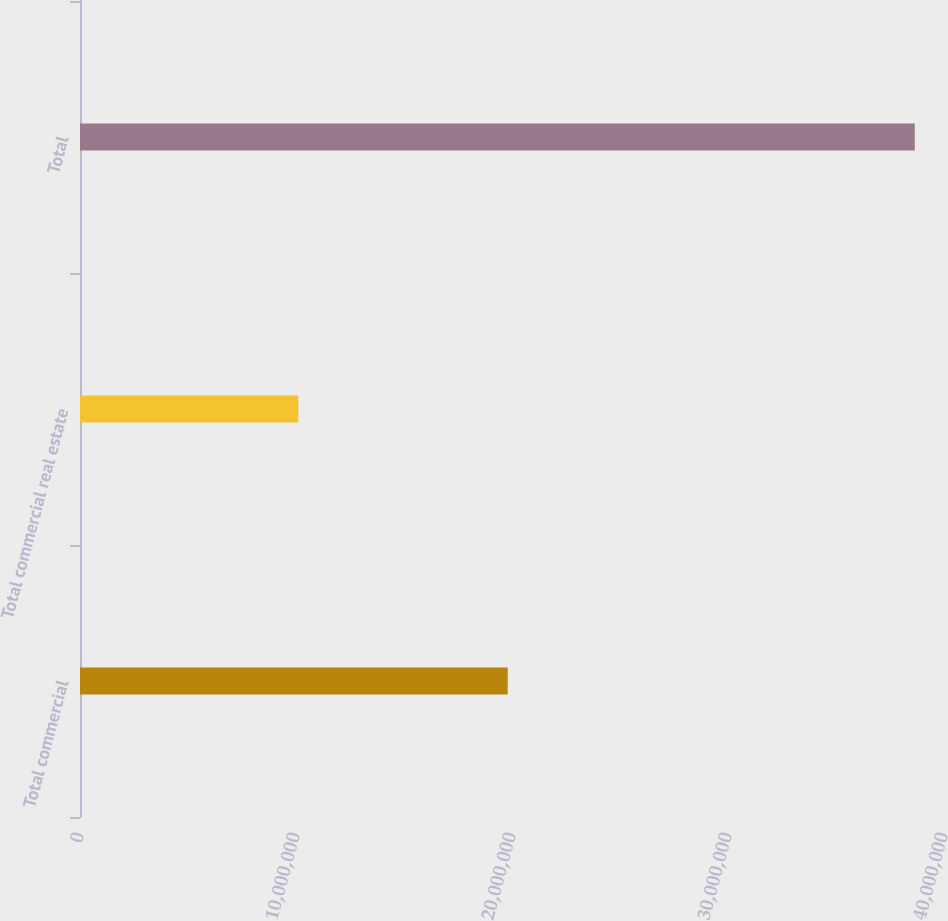Convert chart to OTSL. <chart><loc_0><loc_0><loc_500><loc_500><bar_chart><fcel>Total commercial<fcel>Total commercial real estate<fcel>Total<nl><fcel>1.98022e+07<fcel>1.0106e+07<fcel>3.86471e+07<nl></chart> 